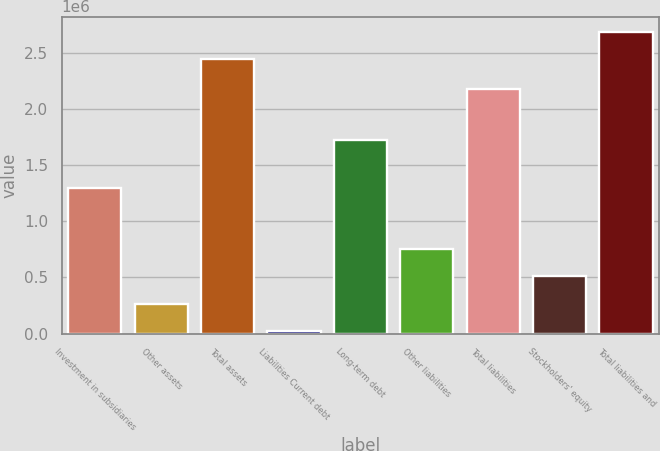Convert chart. <chart><loc_0><loc_0><loc_500><loc_500><bar_chart><fcel>Investment in subsidiaries<fcel>Other assets<fcel>Total assets<fcel>Liabilities Current debt<fcel>Long-term debt<fcel>Other liabilities<fcel>Total liabilities<fcel>Stockholders' equity<fcel>Total liabilities and<nl><fcel>1.29904e+06<fcel>266730<fcel>2.44995e+06<fcel>24150<fcel>1.72478e+06<fcel>751890<fcel>2.17717e+06<fcel>509310<fcel>2.69253e+06<nl></chart> 